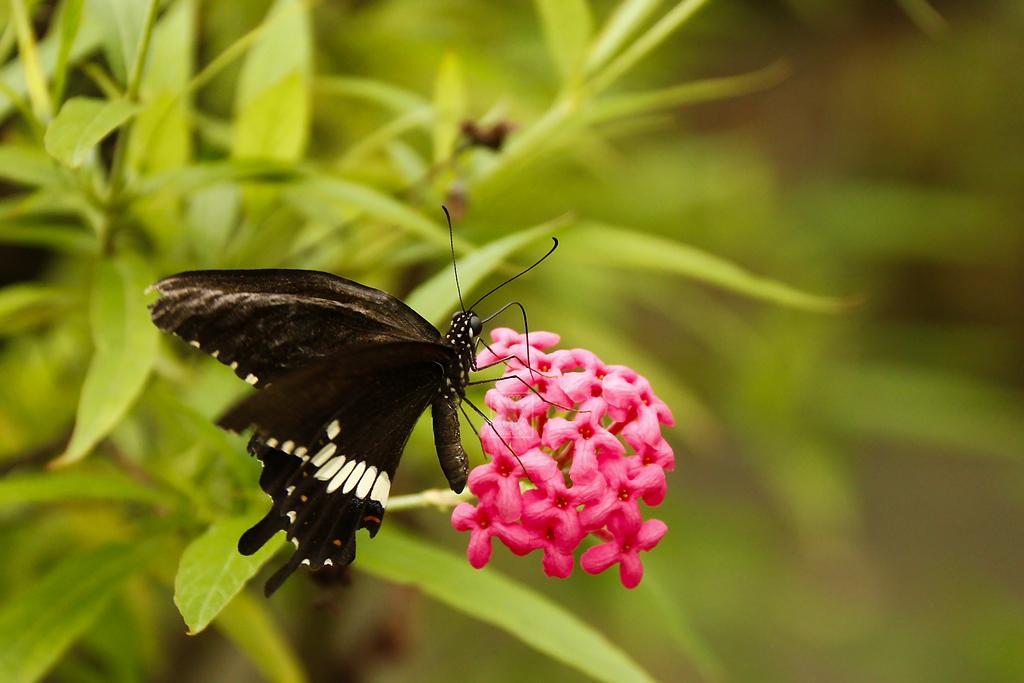How would you summarize this image in a sentence or two? In this image we can see there is an insect sitting on the flower and this insect is of black and white color. 